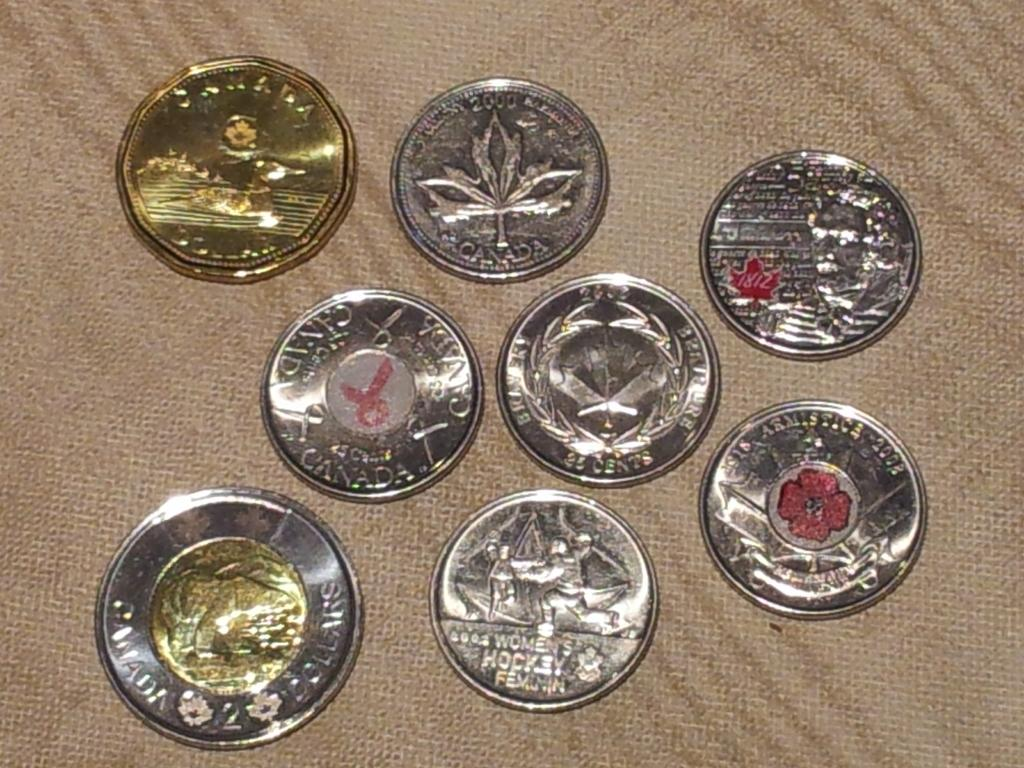<image>
Write a terse but informative summary of the picture. A number of silver coins, one of which has the words 'women's hockey' on the bottom. 